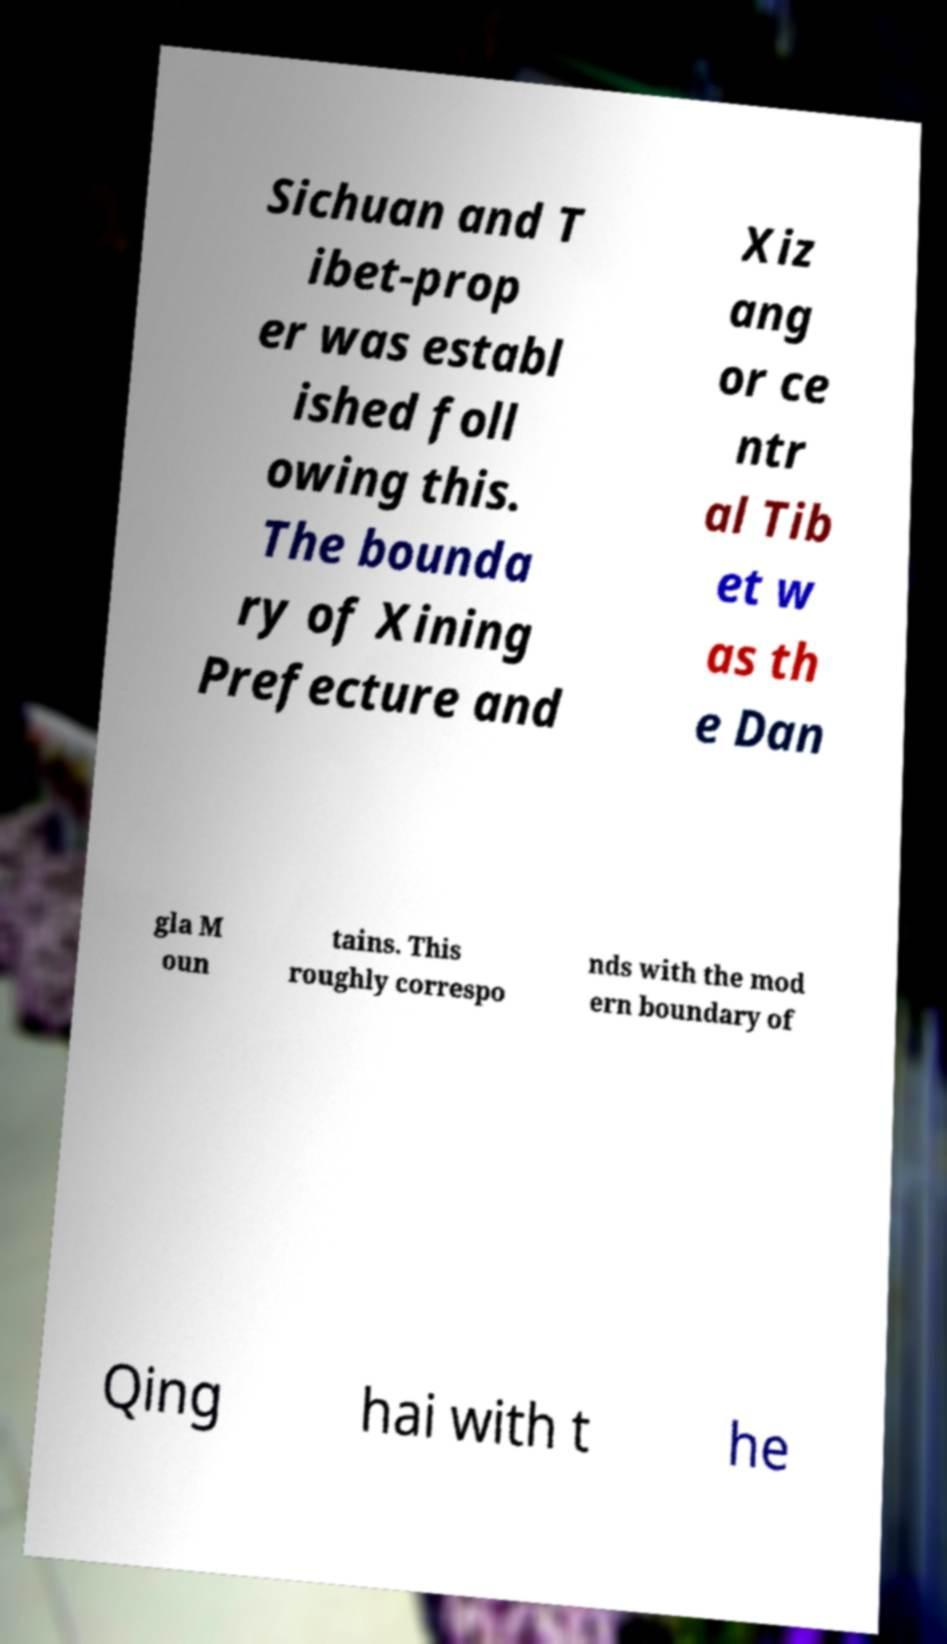Could you extract and type out the text from this image? Sichuan and T ibet-prop er was establ ished foll owing this. The bounda ry of Xining Prefecture and Xiz ang or ce ntr al Tib et w as th e Dan gla M oun tains. This roughly correspo nds with the mod ern boundary of Qing hai with t he 